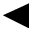<formula> <loc_0><loc_0><loc_500><loc_500>\blacktriangleleft</formula> 